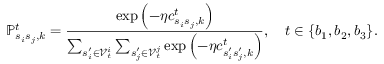Convert formula to latex. <formula><loc_0><loc_0><loc_500><loc_500>\mathbb { P } _ { s _ { i } s _ { j } , k } ^ { t } = \frac { \exp { \left ( - \eta c _ { s _ { i } s _ { j } , k } ^ { t } \right ) } } { \sum _ { s _ { i } ^ { \prime } \in \mathcal { V } _ { t } ^ { i } } \sum _ { s _ { j } ^ { \prime } \in \mathcal { V } _ { t } ^ { j } } \exp { \left ( - \eta c _ { s _ { i } ^ { \prime } s _ { j } ^ { \prime } , k } ^ { t } \right ) } } , \quad t \in \{ b _ { 1 } , b _ { 2 } , b _ { 3 } \} .</formula> 